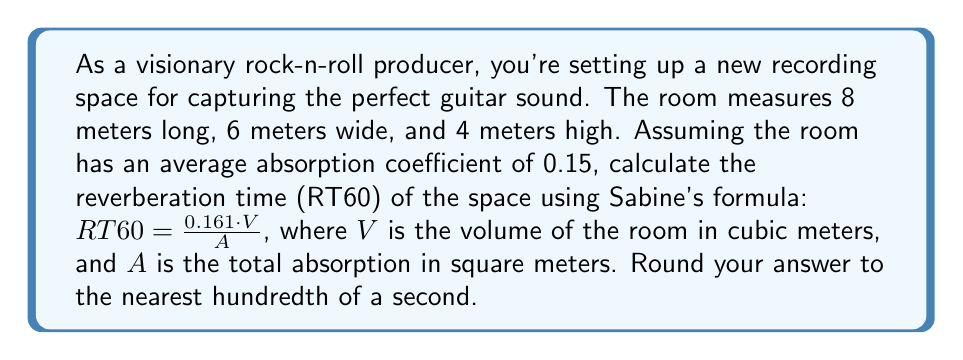Teach me how to tackle this problem. To solve this problem, we'll follow these steps:

1. Calculate the volume (V) of the room:
   $V = length \cdot width \cdot height$
   $V = 8 \text{ m} \cdot 6 \text{ m} \cdot 4 \text{ m} = 192 \text{ m}^3$

2. Calculate the total surface area (S) of the room:
   $S = 2(length \cdot width + length \cdot height + width \cdot height)$
   $S = 2(8 \text{ m} \cdot 6 \text{ m} + 8 \text{ m} \cdot 4 \text{ m} + 6 \text{ m} \cdot 4 \text{ m})$
   $S = 2(48 \text{ m}^2 + 32 \text{ m}^2 + 24 \text{ m}^2) = 2(104 \text{ m}^2) = 208 \text{ m}^2$

3. Calculate the total absorption (A):
   $A = S \cdot \text{average absorption coefficient}$
   $A = 208 \text{ m}^2 \cdot 0.15 = 31.2 \text{ m}^2$

4. Apply Sabine's formula:
   $$RT60 = \frac{0.161 \cdot V}{A}$$
   $$RT60 = \frac{0.161 \cdot 192 \text{ m}^3}{31.2 \text{ m}^2}$$
   $$RT60 = \frac{30.912}{31.2} \approx 0.9907 \text{ seconds}$$

5. Round to the nearest hundredth:
   $RT60 \approx 0.99 \text{ seconds}$
Answer: 0.99 seconds 